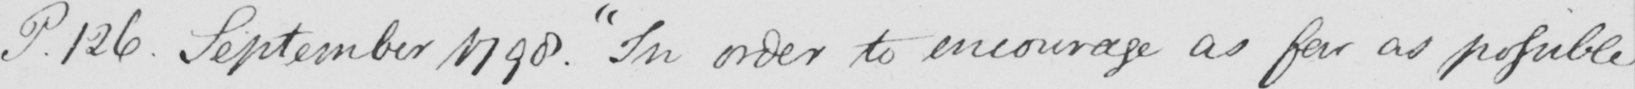Please transcribe the handwritten text in this image. P. 126. September 1790. "In order to encourage as far as possible 